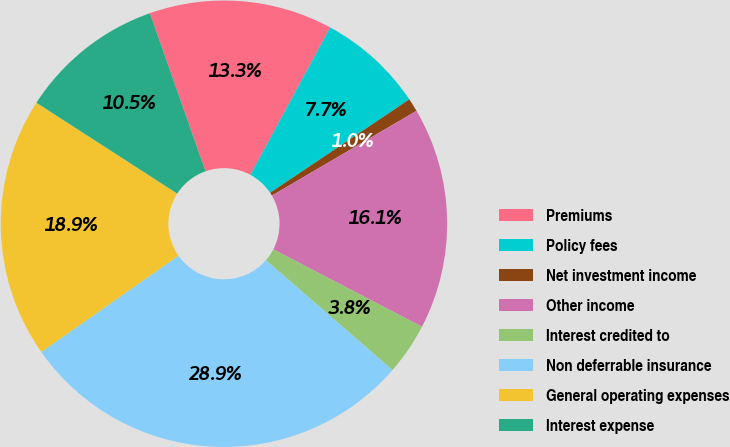Convert chart to OTSL. <chart><loc_0><loc_0><loc_500><loc_500><pie_chart><fcel>Premiums<fcel>Policy fees<fcel>Net investment income<fcel>Other income<fcel>Interest credited to<fcel>Non deferrable insurance<fcel>General operating expenses<fcel>Interest expense<nl><fcel>13.28%<fcel>7.7%<fcel>0.96%<fcel>16.07%<fcel>3.75%<fcel>28.87%<fcel>18.86%<fcel>10.49%<nl></chart> 